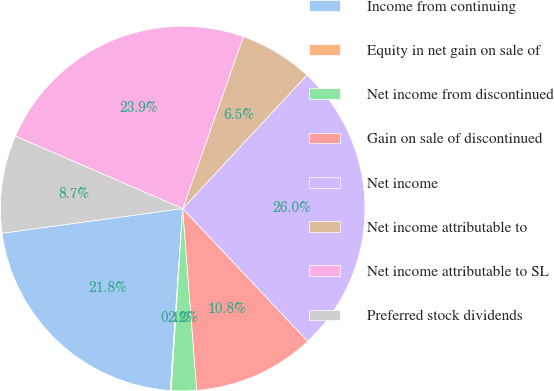<chart> <loc_0><loc_0><loc_500><loc_500><pie_chart><fcel>Income from continuing<fcel>Equity in net gain on sale of<fcel>Net income from discontinued<fcel>Gain on sale of discontinued<fcel>Net income<fcel>Net income attributable to<fcel>Net income attributable to SL<fcel>Preferred stock dividends<nl><fcel>21.75%<fcel>0.09%<fcel>2.23%<fcel>10.8%<fcel>26.04%<fcel>6.52%<fcel>23.9%<fcel>8.66%<nl></chart> 